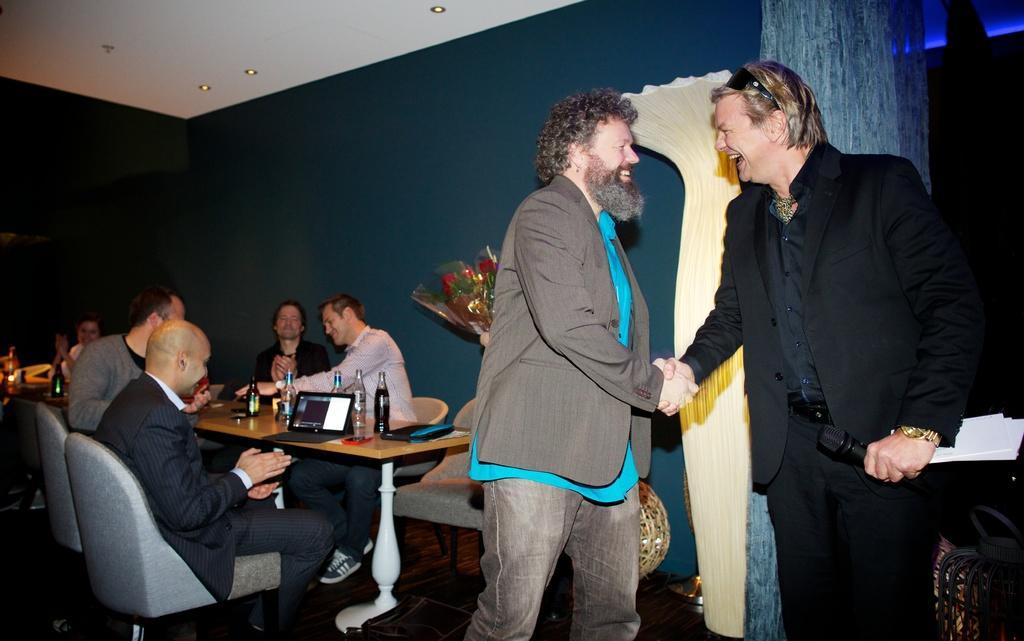Describe this image in one or two sentences. Here we can see two persons are standing and smiling, and here a group of persons are sitting on the chair, and here is the table and laptop and wine bottles on it, and here is the wall. 